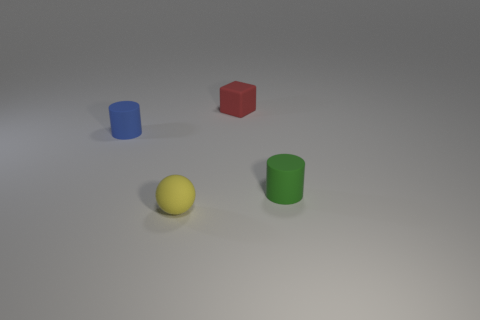Are there an equal number of yellow rubber objects that are in front of the yellow ball and small yellow matte balls behind the small blue matte object?
Provide a short and direct response. Yes. How many tiny matte blocks are there?
Your answer should be very brief. 1. Is the number of yellow rubber objects to the left of the small blue rubber thing greater than the number of tiny red things?
Your answer should be very brief. No. What is the material of the tiny cylinder on the left side of the small green cylinder?
Your answer should be compact. Rubber. There is another rubber object that is the same shape as the green thing; what is its color?
Make the answer very short. Blue. What number of small matte cubes have the same color as the tiny rubber sphere?
Your response must be concise. 0. There is a rubber thing to the left of the tiny sphere; is it the same size as the rubber thing that is in front of the green cylinder?
Your response must be concise. Yes. Does the red object have the same size as the thing that is in front of the small green thing?
Give a very brief answer. Yes. What is the size of the green matte object?
Provide a short and direct response. Small. What color is the small block that is the same material as the tiny sphere?
Offer a very short reply. Red. 